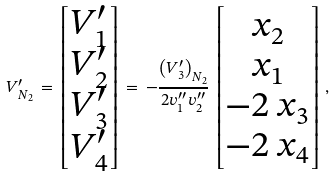<formula> <loc_0><loc_0><loc_500><loc_500>V ^ { \prime } _ { N _ { 2 } } \, = \, \begin{bmatrix} V ^ { \prime } _ { 1 } \\ V ^ { \prime } _ { 2 } \\ V ^ { \prime } _ { 3 } \\ V ^ { \prime } _ { 4 } \end{bmatrix} \, = \, - \frac { \left ( V ^ { \prime } _ { 3 } \right ) _ { N _ { 2 } } } { 2 v ^ { \prime \prime } _ { 1 } v ^ { \prime \prime } _ { 2 } } \, \begin{bmatrix} x _ { 2 } \\ x _ { 1 } \\ - 2 \, x _ { 3 } \\ - 2 \, x _ { 4 } \end{bmatrix} \, ,</formula> 